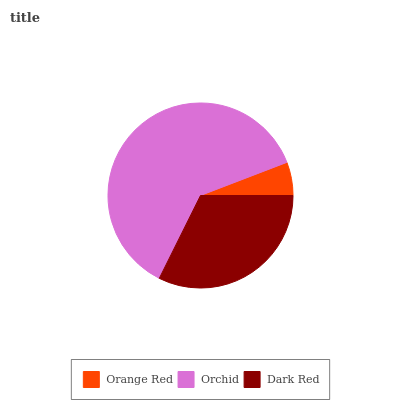Is Orange Red the minimum?
Answer yes or no. Yes. Is Orchid the maximum?
Answer yes or no. Yes. Is Dark Red the minimum?
Answer yes or no. No. Is Dark Red the maximum?
Answer yes or no. No. Is Orchid greater than Dark Red?
Answer yes or no. Yes. Is Dark Red less than Orchid?
Answer yes or no. Yes. Is Dark Red greater than Orchid?
Answer yes or no. No. Is Orchid less than Dark Red?
Answer yes or no. No. Is Dark Red the high median?
Answer yes or no. Yes. Is Dark Red the low median?
Answer yes or no. Yes. Is Orange Red the high median?
Answer yes or no. No. Is Orchid the low median?
Answer yes or no. No. 